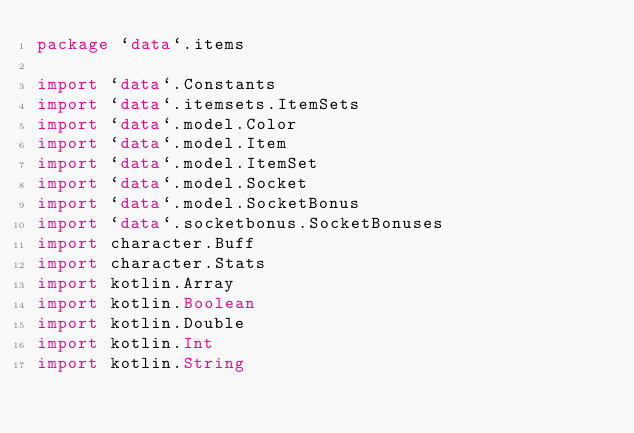<code> <loc_0><loc_0><loc_500><loc_500><_Kotlin_>package `data`.items

import `data`.Constants
import `data`.itemsets.ItemSets
import `data`.model.Color
import `data`.model.Item
import `data`.model.ItemSet
import `data`.model.Socket
import `data`.model.SocketBonus
import `data`.socketbonus.SocketBonuses
import character.Buff
import character.Stats
import kotlin.Array
import kotlin.Boolean
import kotlin.Double
import kotlin.Int
import kotlin.String</code> 